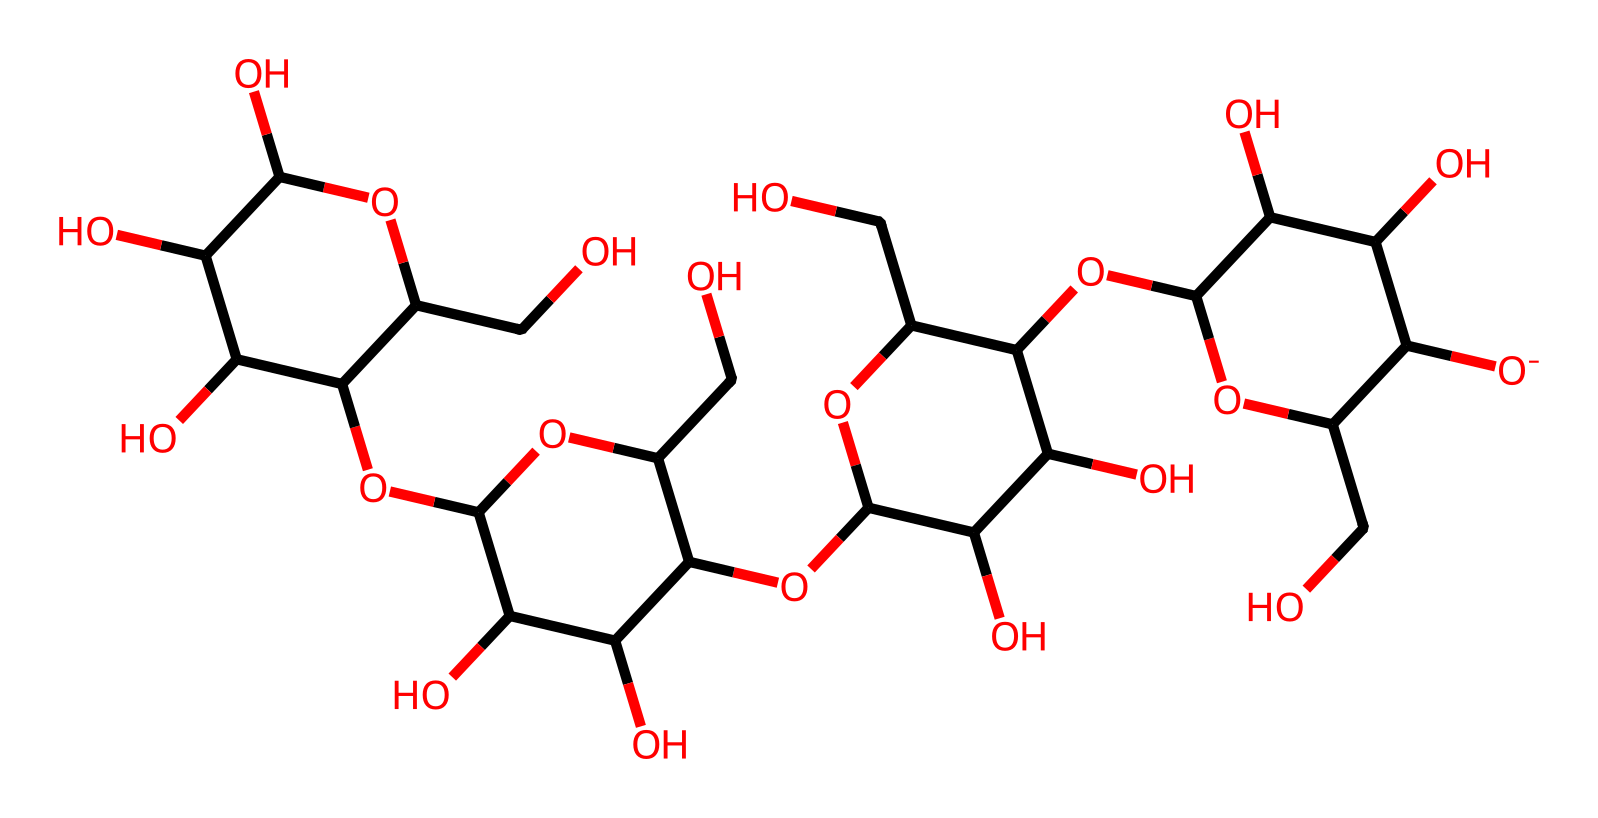What is the primary organic compound represented by this SMILES? The SMILES notation represents cellulose, which is a polysaccharide made up of repeating glucose units.
Answer: cellulose How many rings are present in this chemical structure? The SMILES indicates multiple cyclic structures due to the presence of several 'C' atoms connected in a cyclic manner; there are 4 rings in the structure.
Answer: 4 What functional groups are present in this molecule? The molecule contains hydroxyl (–OH) functional groups which are indicated by the presence of various 'O' atoms connected to the carbon chains.
Answer: hydroxyl groups What is the molecular formula for cellulose based on the SMILES? By analyzing the count of carbon (C), hydrogen (H), and oxygen (O) atoms from the structure, the molecular formula can be deduced as C6H10O5 for each glucose unit, and assuming a polymeric form, it can be represented generally as (C6H10O5)n.
Answer: (C6H10O5)n How does the structure of cellulose contribute to its structural properties? Cellulose’s long chain of glucose monomers and extensive hydrogen bonding between chains give it high tensile strength, making it a vital structural component in plants.
Answer: tensile strength 